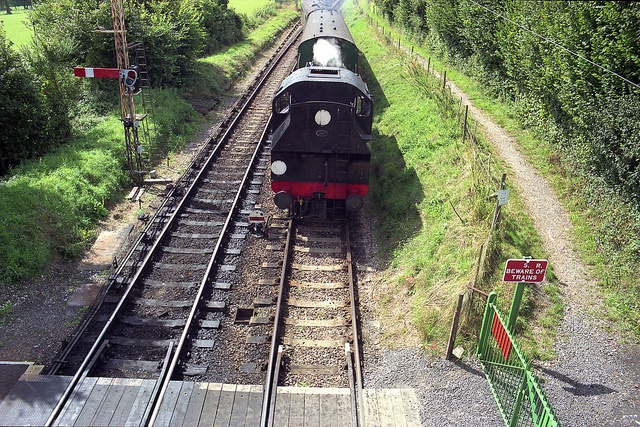Describe the objects in this image and their specific colors. I can see train in black, lightgray, maroon, and darkgray tones and traffic light in black, gray, and darkgray tones in this image. 